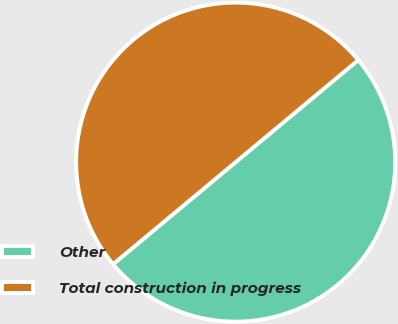Convert chart. <chart><loc_0><loc_0><loc_500><loc_500><pie_chart><fcel>Other<fcel>Total construction in progress<nl><fcel>50.0%<fcel>50.0%<nl></chart> 